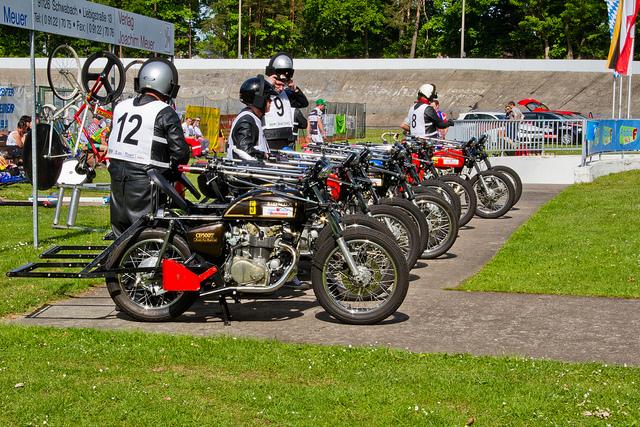How many different numbers do you see?
Be succinct. 3. How many motorcycles are there?
Answer briefly. 9. What are they getting ready to do?
Short answer required. Race. 